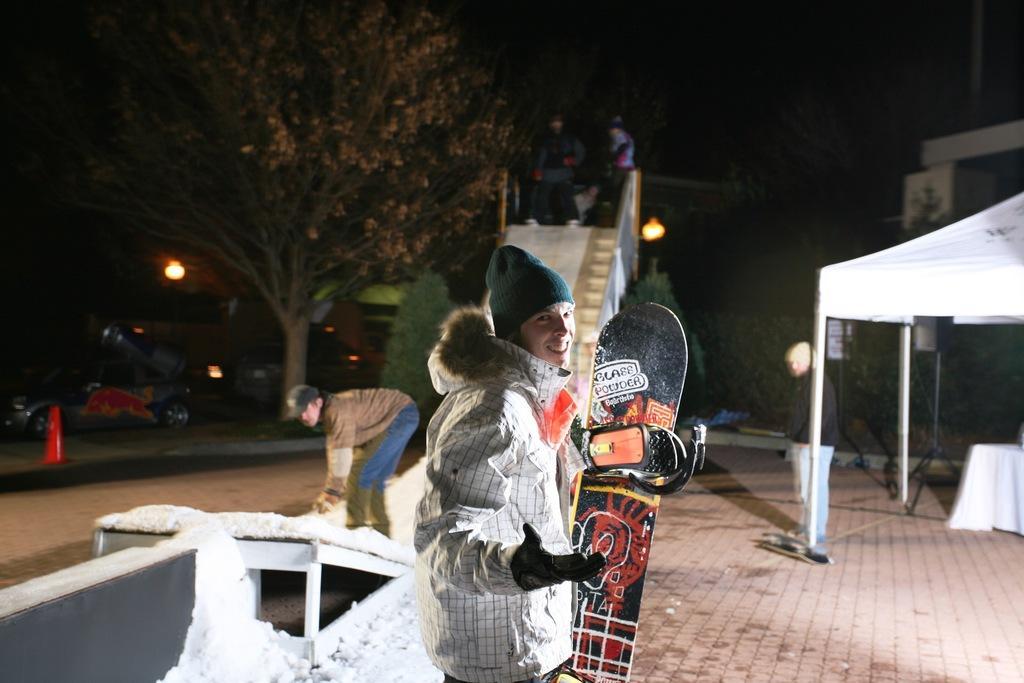In one or two sentences, can you explain what this image depicts? In this Image I see a man who is standing and smiling and holding a skateboard in his hand. In the background I see few people on the path and I see the snow, cars on the road, trees and the light. 